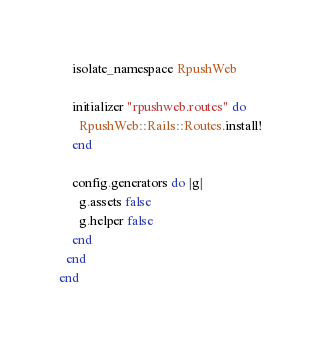Convert code to text. <code><loc_0><loc_0><loc_500><loc_500><_Ruby_>    isolate_namespace RpushWeb

    initializer "rpushweb.routes" do
      RpushWeb::Rails::Routes.install!
    end

    config.generators do |g|
      g.assets false
      g.helper false
    end
  end
end
</code> 